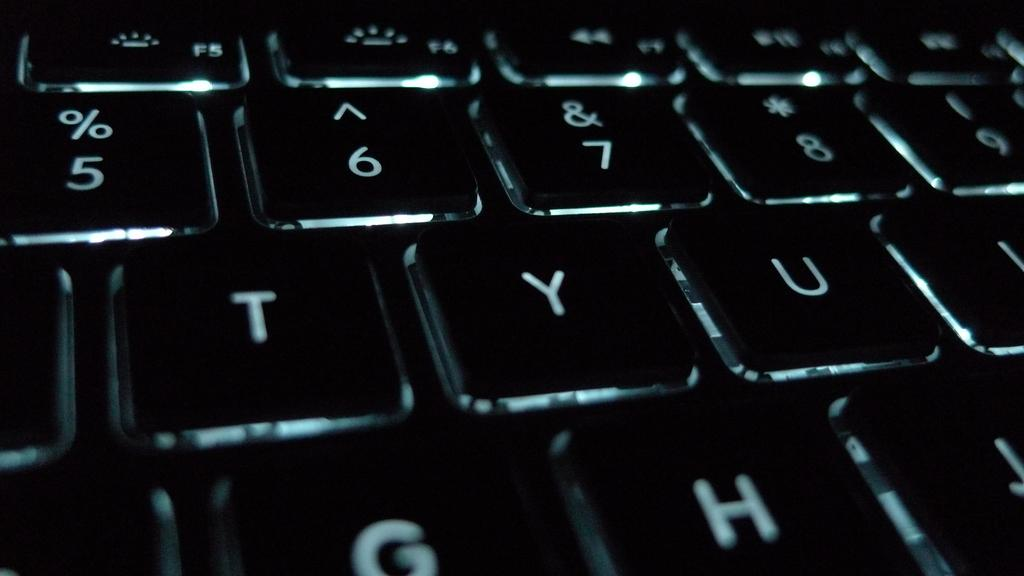<image>
Summarize the visual content of the image. A closeup of a keyboard with the letters TYU 